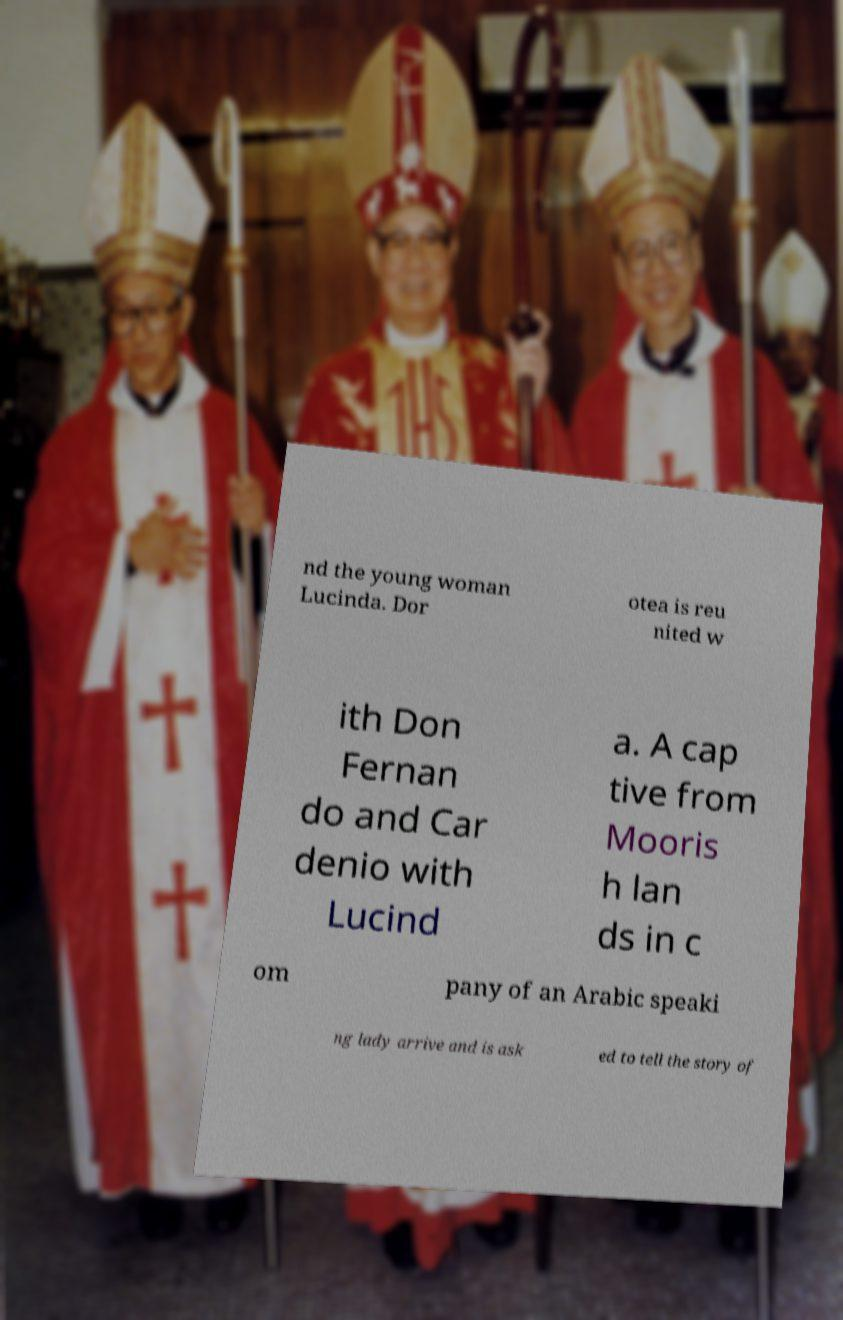What messages or text are displayed in this image? I need them in a readable, typed format. nd the young woman Lucinda. Dor otea is reu nited w ith Don Fernan do and Car denio with Lucind a. A cap tive from Mooris h lan ds in c om pany of an Arabic speaki ng lady arrive and is ask ed to tell the story of 